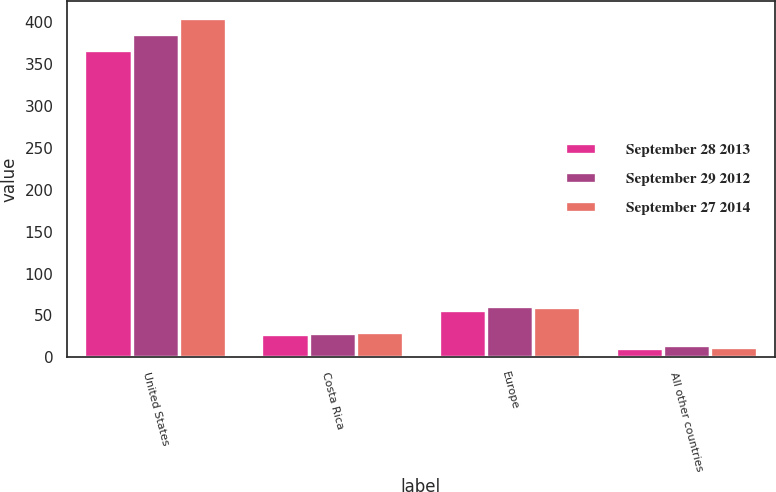<chart> <loc_0><loc_0><loc_500><loc_500><stacked_bar_chart><ecel><fcel>United States<fcel>Costa Rica<fcel>Europe<fcel>All other countries<nl><fcel>September 28 2013<fcel>366.8<fcel>27.9<fcel>56<fcel>11.2<nl><fcel>September 29 2012<fcel>386<fcel>29.3<fcel>61.5<fcel>14.7<nl><fcel>September 27 2014<fcel>405.1<fcel>30.5<fcel>59.9<fcel>12.5<nl></chart> 